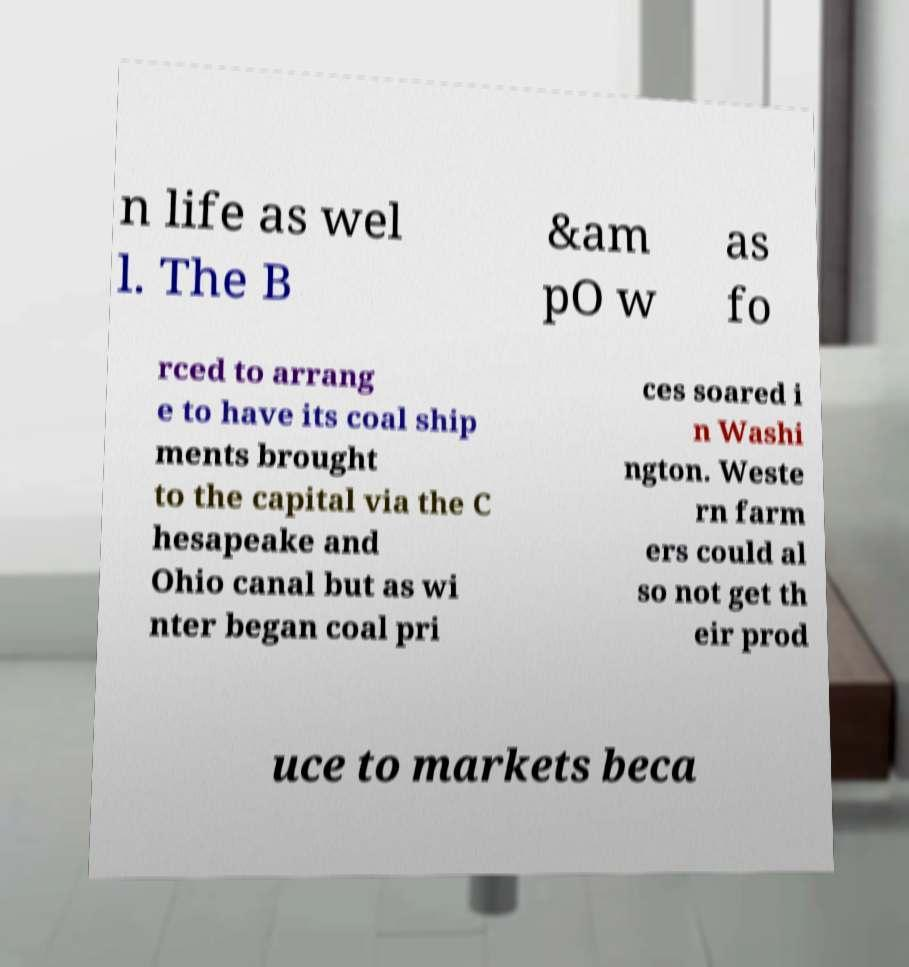Could you assist in decoding the text presented in this image and type it out clearly? n life as wel l. The B &am pO w as fo rced to arrang e to have its coal ship ments brought to the capital via the C hesapeake and Ohio canal but as wi nter began coal pri ces soared i n Washi ngton. Weste rn farm ers could al so not get th eir prod uce to markets beca 